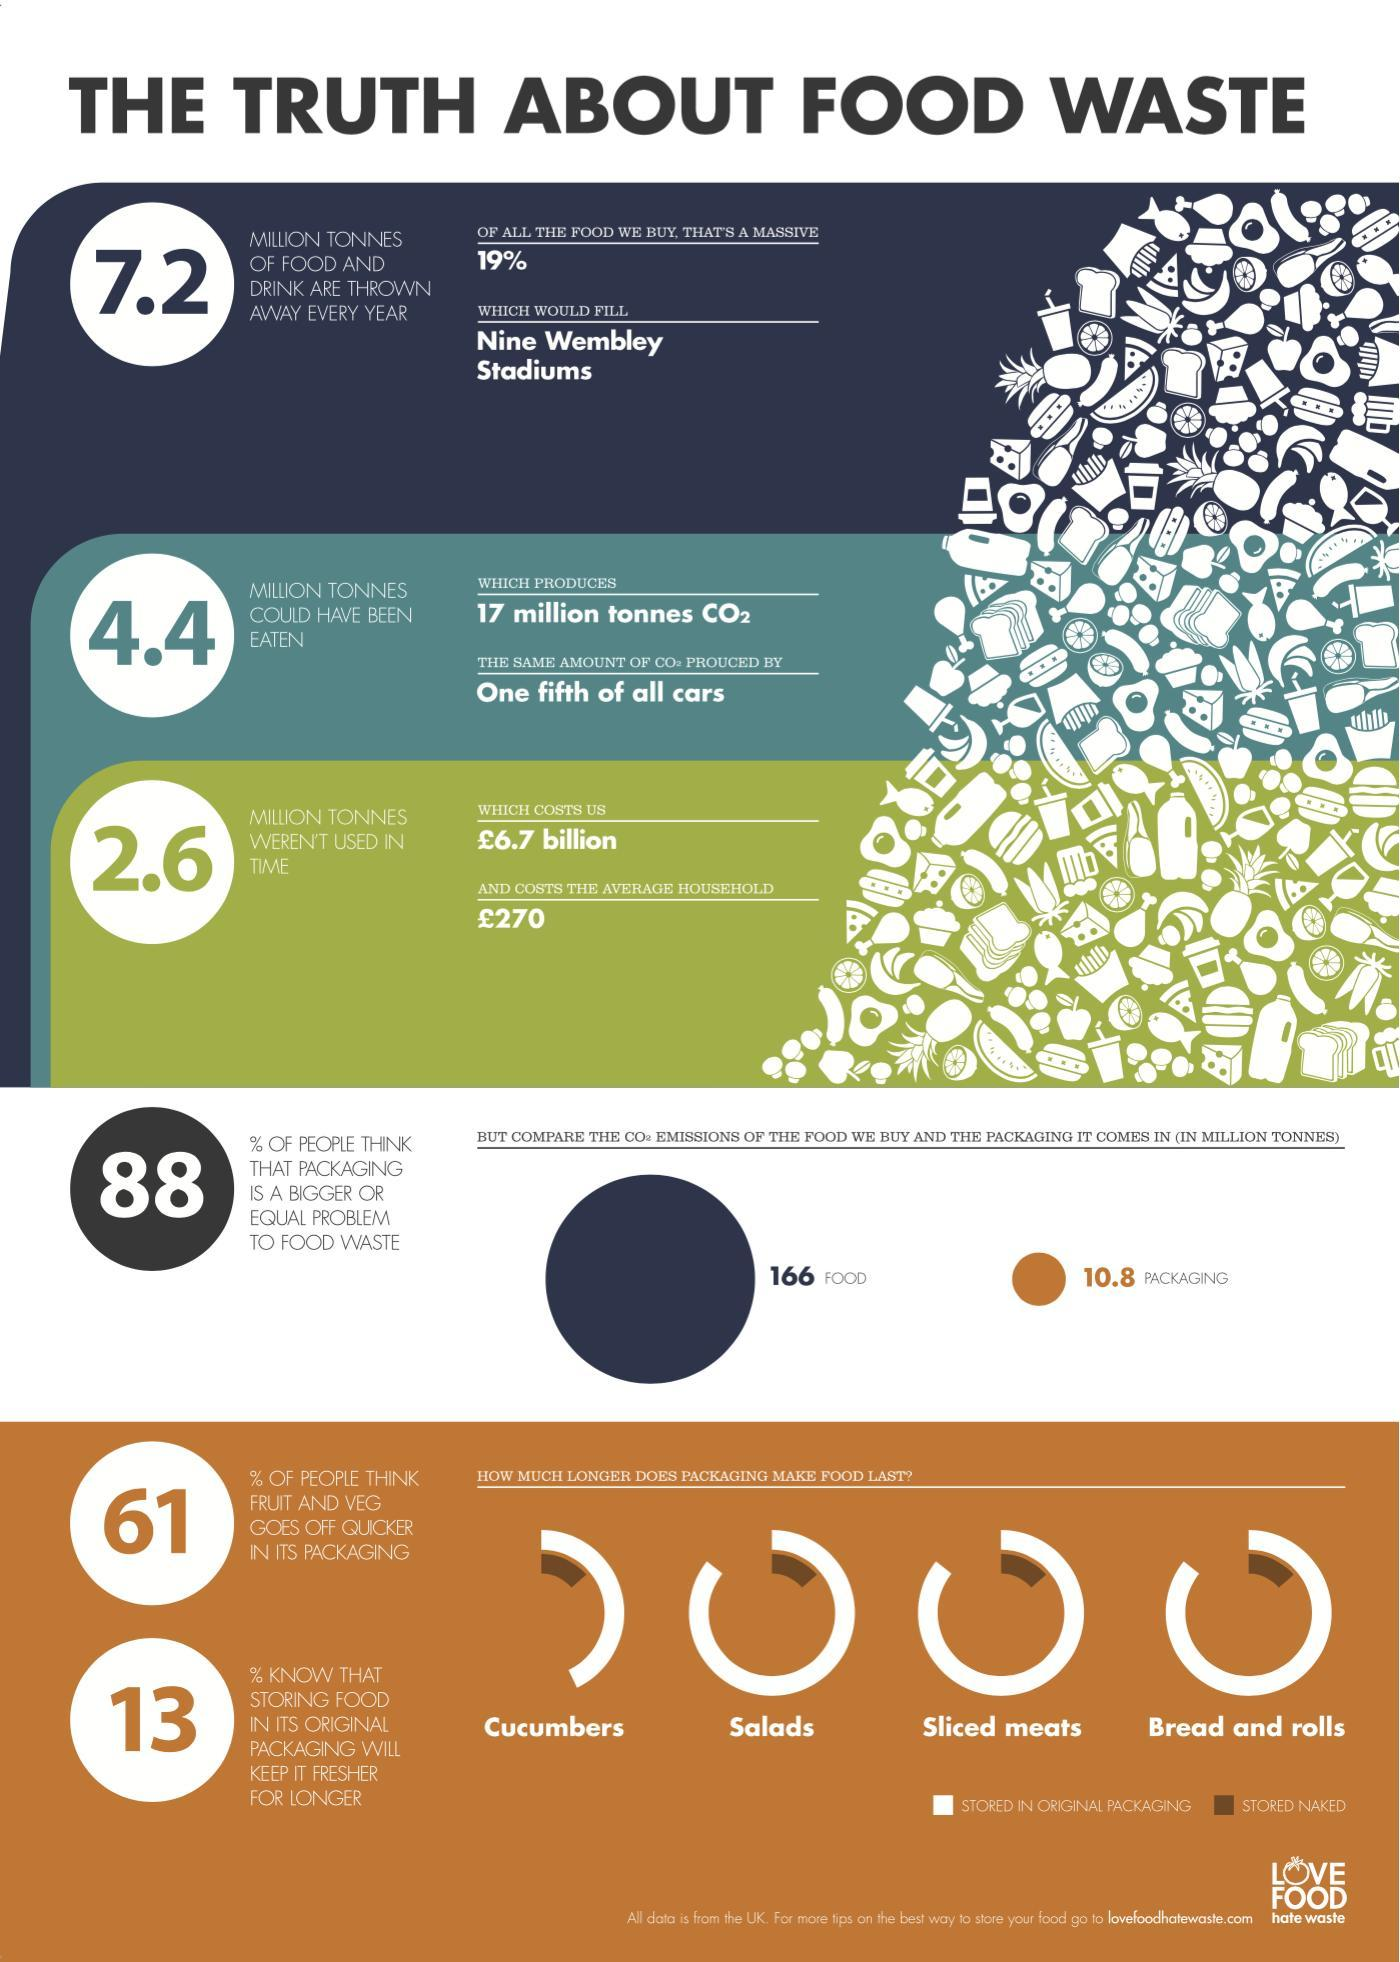What percent of people in UK do not know that storing food in its original packaging will keep it fresher for longer?
Answer the question with a short phrase. 87% What percentage of people in UK think that packaging is not a bigger or equal problem to food waste? 12% 